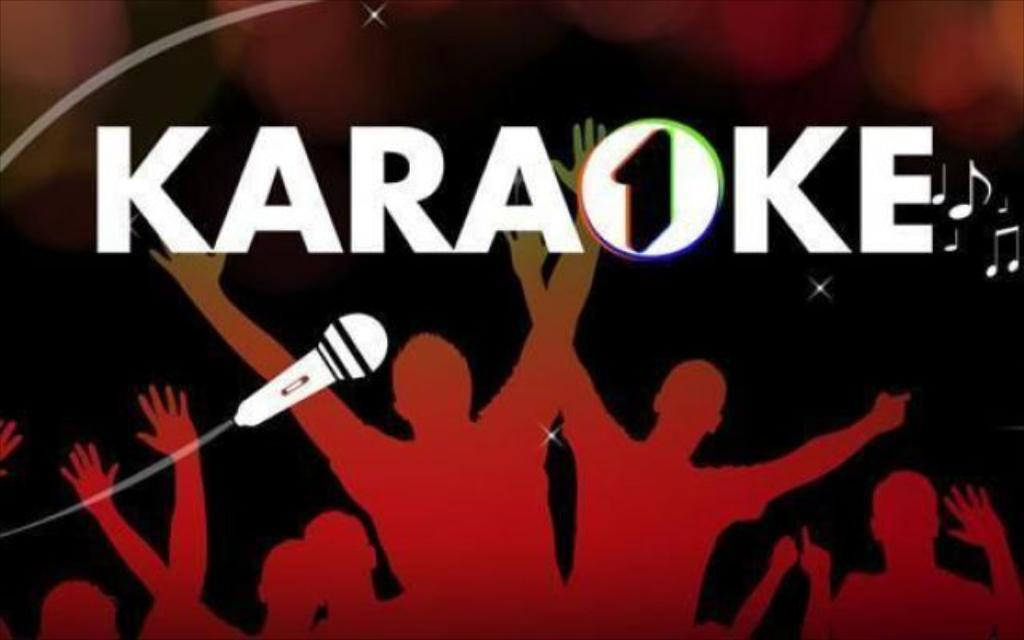<image>
Create a compact narrative representing the image presented. A group of adults with their hands in the air for karaoke. 